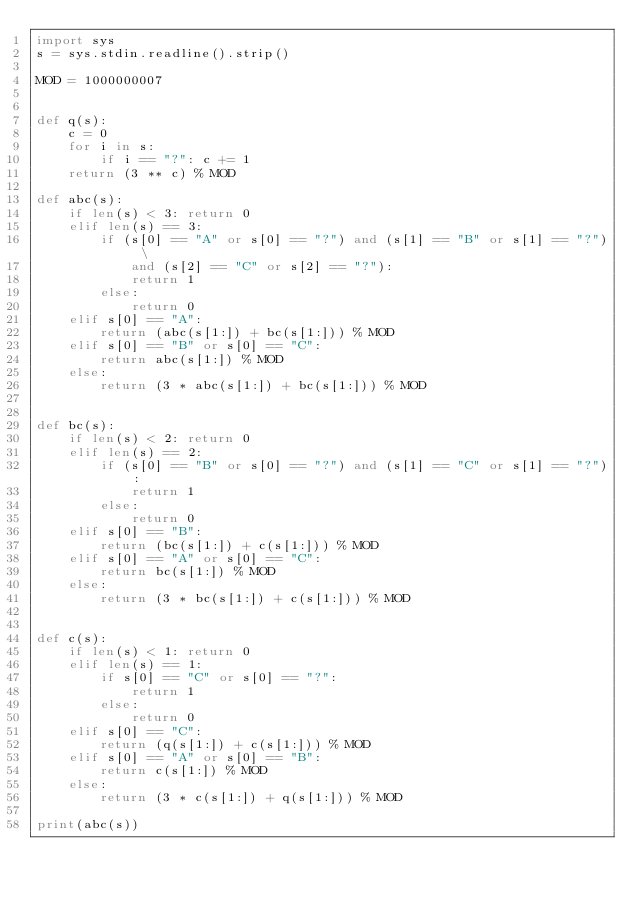<code> <loc_0><loc_0><loc_500><loc_500><_Python_>import sys
s = sys.stdin.readline().strip()

MOD = 1000000007


def q(s):
    c = 0
    for i in s:
        if i == "?": c += 1
    return (3 ** c) % MOD

def abc(s):
    if len(s) < 3: return 0
    elif len(s) == 3:
        if (s[0] == "A" or s[0] == "?") and (s[1] == "B" or s[1] == "?") \
            and (s[2] == "C" or s[2] == "?"):
            return 1
        else:
            return 0
    elif s[0] == "A":
        return (abc(s[1:]) + bc(s[1:])) % MOD
    elif s[0] == "B" or s[0] == "C":
        return abc(s[1:]) % MOD
    else:
        return (3 * abc(s[1:]) + bc(s[1:])) % MOD


def bc(s):
    if len(s) < 2: return 0
    elif len(s) == 2:
        if (s[0] == "B" or s[0] == "?") and (s[1] == "C" or s[1] == "?"):
            return 1
        else:
            return 0
    elif s[0] == "B":
        return (bc(s[1:]) + c(s[1:])) % MOD
    elif s[0] == "A" or s[0] == "C":
        return bc(s[1:]) % MOD
    else:
        return (3 * bc(s[1:]) + c(s[1:])) % MOD


def c(s):
    if len(s) < 1: return 0
    elif len(s) == 1:
        if s[0] == "C" or s[0] == "?":
            return 1
        else:
            return 0
    elif s[0] == "C":
        return (q(s[1:]) + c(s[1:])) % MOD
    elif s[0] == "A" or s[0] == "B":
        return c(s[1:]) % MOD
    else:
        return (3 * c(s[1:]) + q(s[1:])) % MOD

print(abc(s))
</code> 